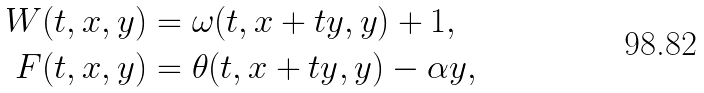<formula> <loc_0><loc_0><loc_500><loc_500>W ( t , x , y ) & = \omega ( t , x + t y , y ) + 1 , \\ F ( t , x , y ) & = \theta ( t , x + t y , y ) - \alpha y ,</formula> 